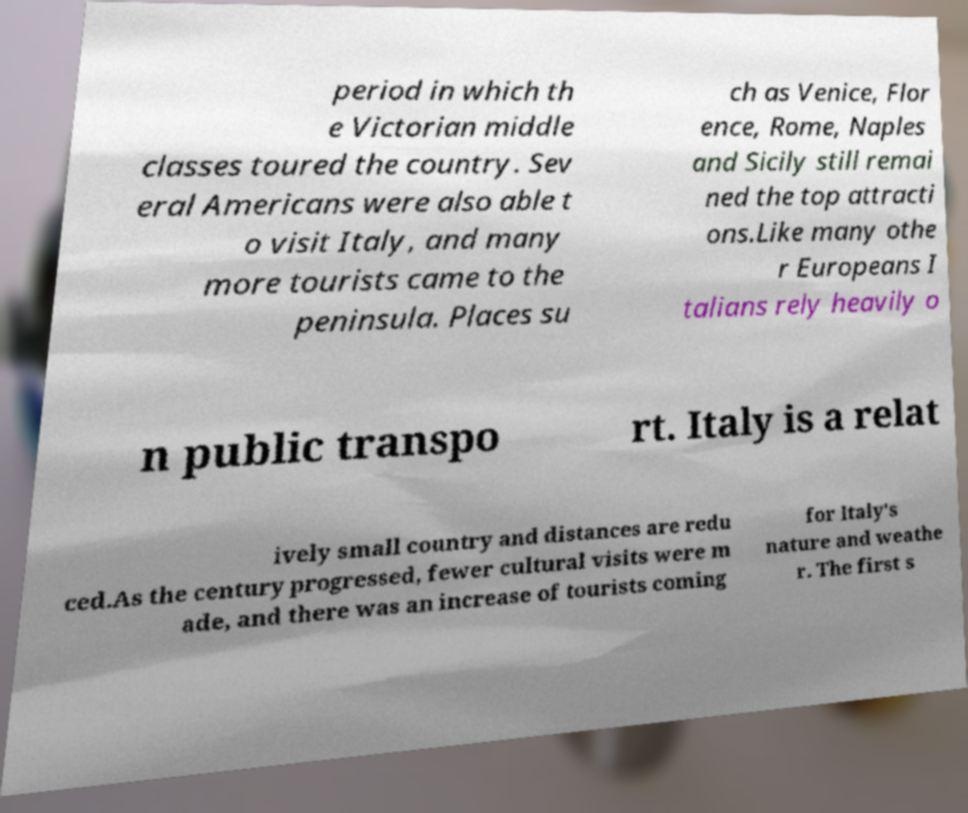Please read and relay the text visible in this image. What does it say? period in which th e Victorian middle classes toured the country. Sev eral Americans were also able t o visit Italy, and many more tourists came to the peninsula. Places su ch as Venice, Flor ence, Rome, Naples and Sicily still remai ned the top attracti ons.Like many othe r Europeans I talians rely heavily o n public transpo rt. Italy is a relat ively small country and distances are redu ced.As the century progressed, fewer cultural visits were m ade, and there was an increase of tourists coming for Italy's nature and weathe r. The first s 